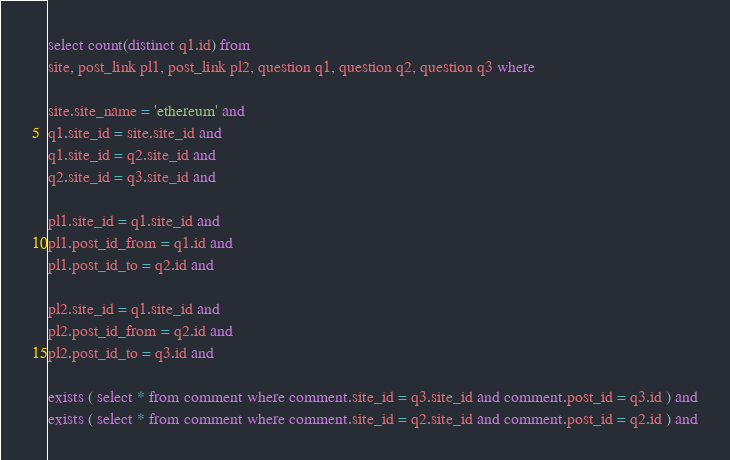<code> <loc_0><loc_0><loc_500><loc_500><_SQL_>
select count(distinct q1.id) from
site, post_link pl1, post_link pl2, question q1, question q2, question q3 where

site.site_name = 'ethereum' and
q1.site_id = site.site_id and
q1.site_id = q2.site_id and
q2.site_id = q3.site_id and

pl1.site_id = q1.site_id and
pl1.post_id_from = q1.id and
pl1.post_id_to = q2.id and

pl2.site_id = q1.site_id and
pl2.post_id_from = q2.id and
pl2.post_id_to = q3.id and

exists ( select * from comment where comment.site_id = q3.site_id and comment.post_id = q3.id ) and
exists ( select * from comment where comment.site_id = q2.site_id and comment.post_id = q2.id ) and</code> 